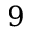Convert formula to latex. <formula><loc_0><loc_0><loc_500><loc_500>9</formula> 